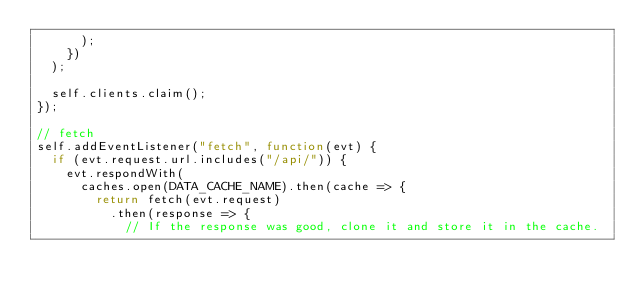Convert code to text. <code><loc_0><loc_0><loc_500><loc_500><_JavaScript_>      );
    })
  );

  self.clients.claim();
});

// fetch
self.addEventListener("fetch", function(evt) {
  if (evt.request.url.includes("/api/")) {
    evt.respondWith(
      caches.open(DATA_CACHE_NAME).then(cache => {
        return fetch(evt.request)
          .then(response => {
            // If the response was good, clone it and store it in the cache.</code> 